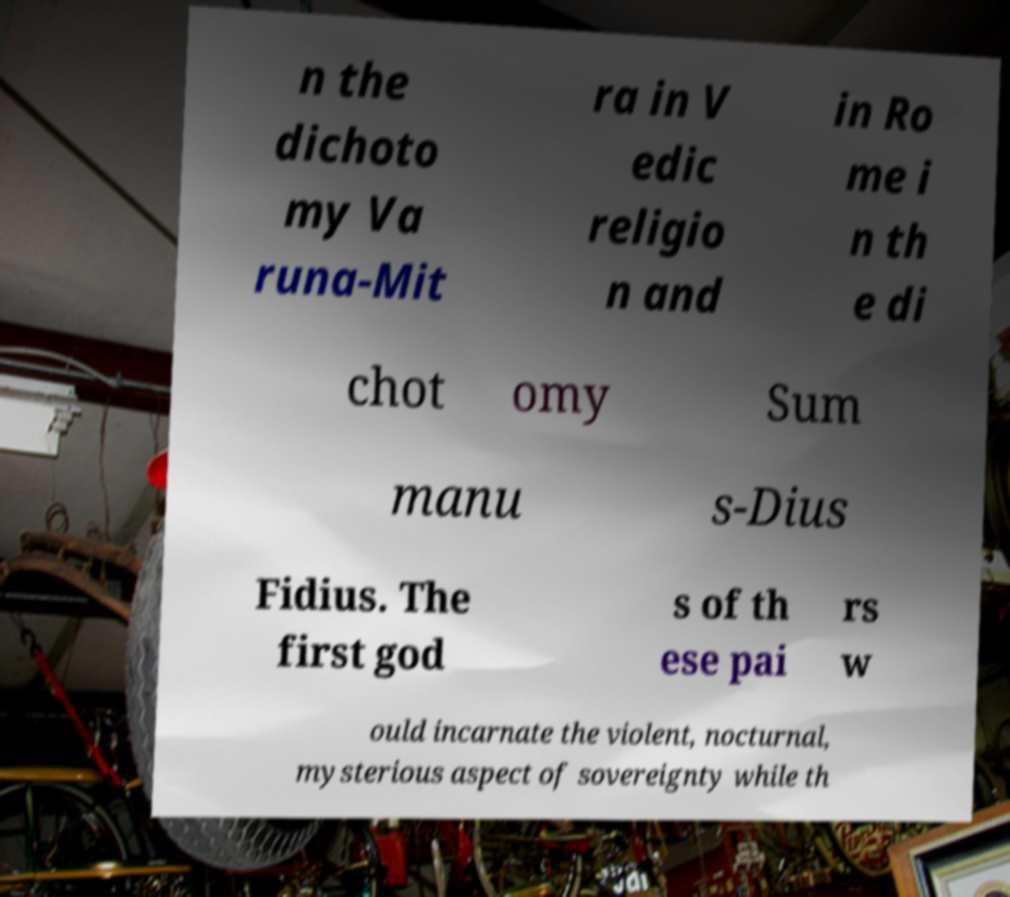Can you read and provide the text displayed in the image?This photo seems to have some interesting text. Can you extract and type it out for me? n the dichoto my Va runa-Mit ra in V edic religio n and in Ro me i n th e di chot omy Sum manu s-Dius Fidius. The first god s of th ese pai rs w ould incarnate the violent, nocturnal, mysterious aspect of sovereignty while th 